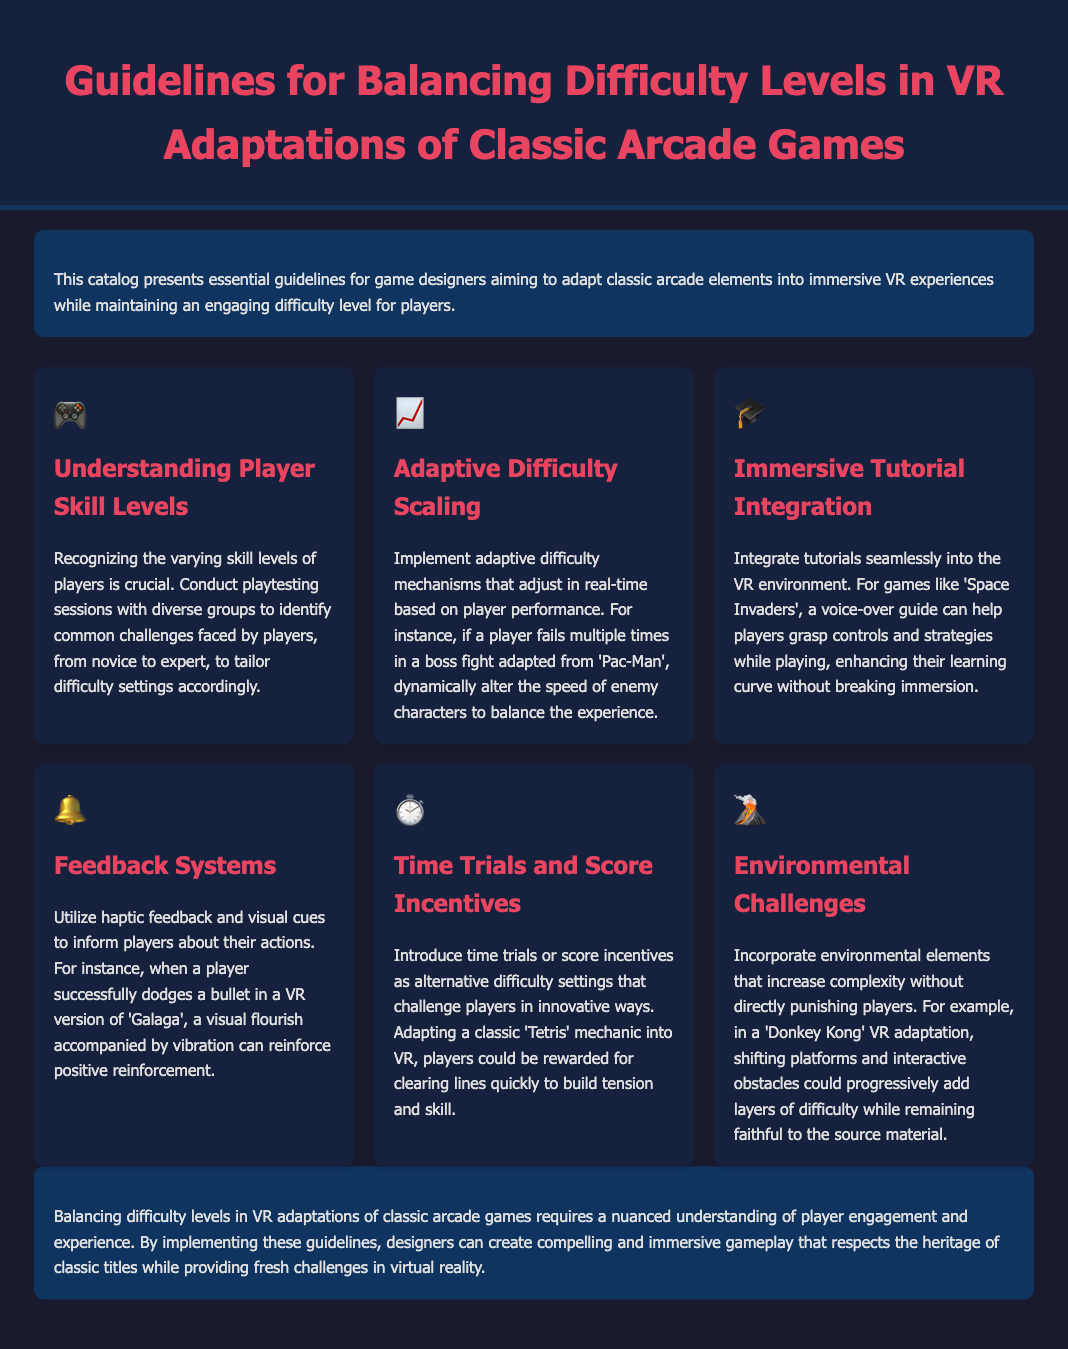What is the title of the catalog? The title is displayed prominently at the top of the document header.
Answer: Guidelines for Balancing Difficulty Levels in VR Adaptations of Classic Arcade Games How many guidelines are presented in the document? The guidelines section contains several distinct entries, which can be counted for total.
Answer: Six What is the purpose of integrating tutorials in VR games? The document outlines the significance of tutorials in helping players learn controls and strategies without losing immersion.
Answer: Enhance their learning curve What icon represents the guideline for Adaptive Difficulty Scaling? The icons serve as visual elements for each guideline, with specific symbols representing them.
Answer: 📈 What game is specifically mentioned in relation to environmental challenges? The document references classic games to illustrate different ideas, including one specific to this category.
Answer: Donkey Kong What method is suggested for providing feedback to players? The guideline discusses employing specific technologies to inform players about their actions in-game.
Answer: Haptic feedback and visual cues What type of challenge is introduced as an alternative difficulty setting? The document suggests a specific way to challenge players which deviates from traditional settings.
Answer: Time trials What is a key factor to consider for player engagement? The overall theme addresses critical elements that maintain a compelling gameplay experience.
Answer: Player skill levels 